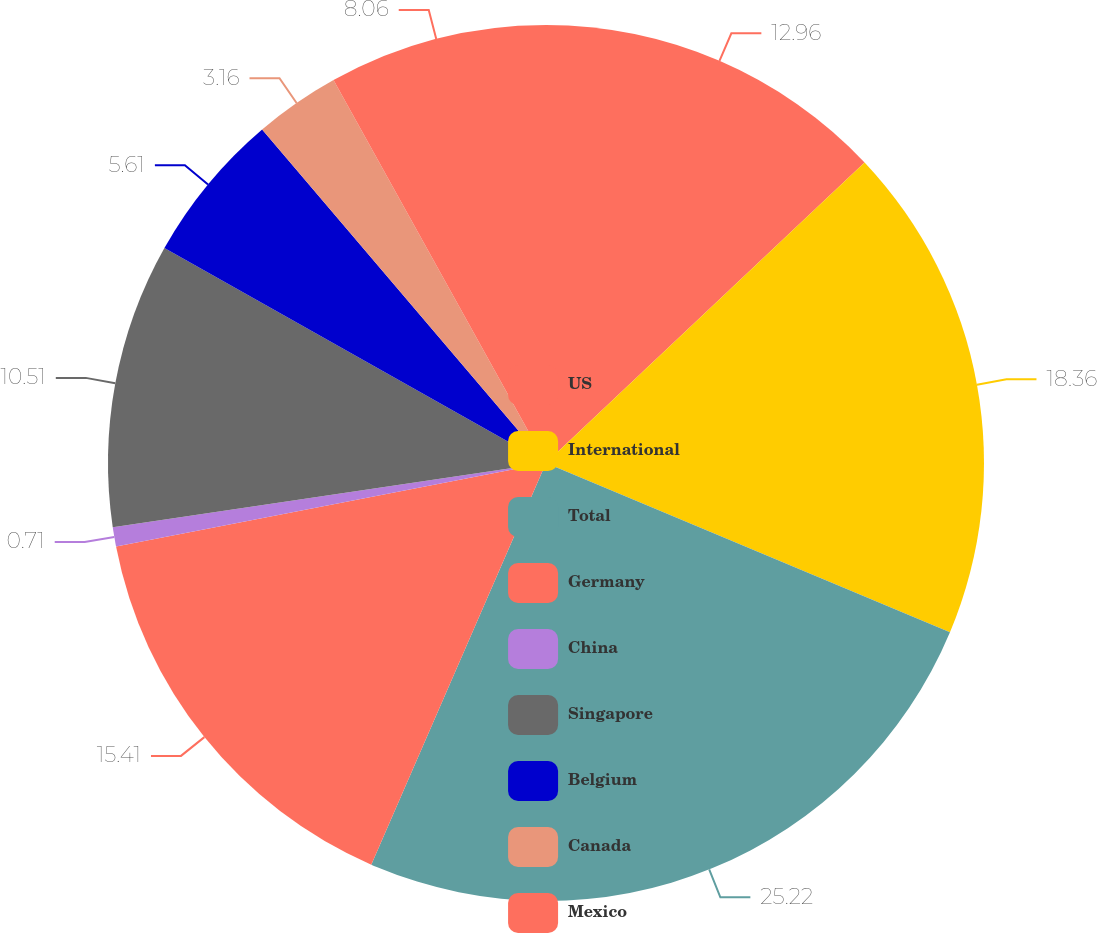<chart> <loc_0><loc_0><loc_500><loc_500><pie_chart><fcel>US<fcel>International<fcel>Total<fcel>Germany<fcel>China<fcel>Singapore<fcel>Belgium<fcel>Canada<fcel>Mexico<nl><fcel>12.96%<fcel>18.35%<fcel>25.21%<fcel>15.41%<fcel>0.71%<fcel>10.51%<fcel>5.61%<fcel>3.16%<fcel>8.06%<nl></chart> 